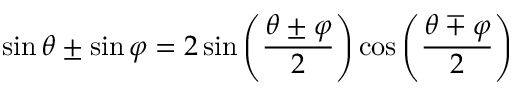Convert formula to latex. <formula><loc_0><loc_0><loc_500><loc_500>\sin \theta \pm \sin \varphi = 2 \sin \left ( { \frac { \theta \pm \varphi } { 2 } } \right ) \cos \left ( { \frac { \theta \mp \varphi } { 2 } } \right )</formula> 